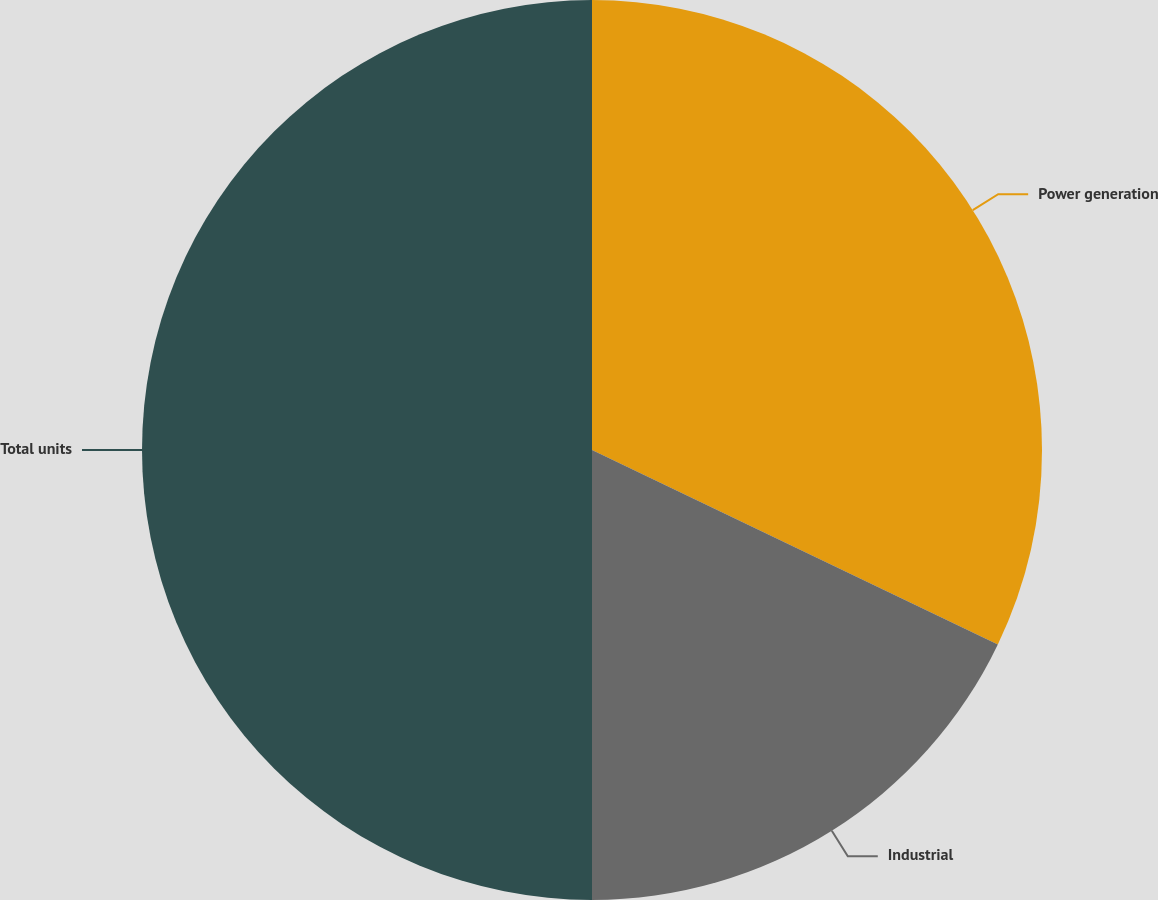Convert chart. <chart><loc_0><loc_0><loc_500><loc_500><pie_chart><fcel>Power generation<fcel>Industrial<fcel>Total units<nl><fcel>32.11%<fcel>17.89%<fcel>50.0%<nl></chart> 